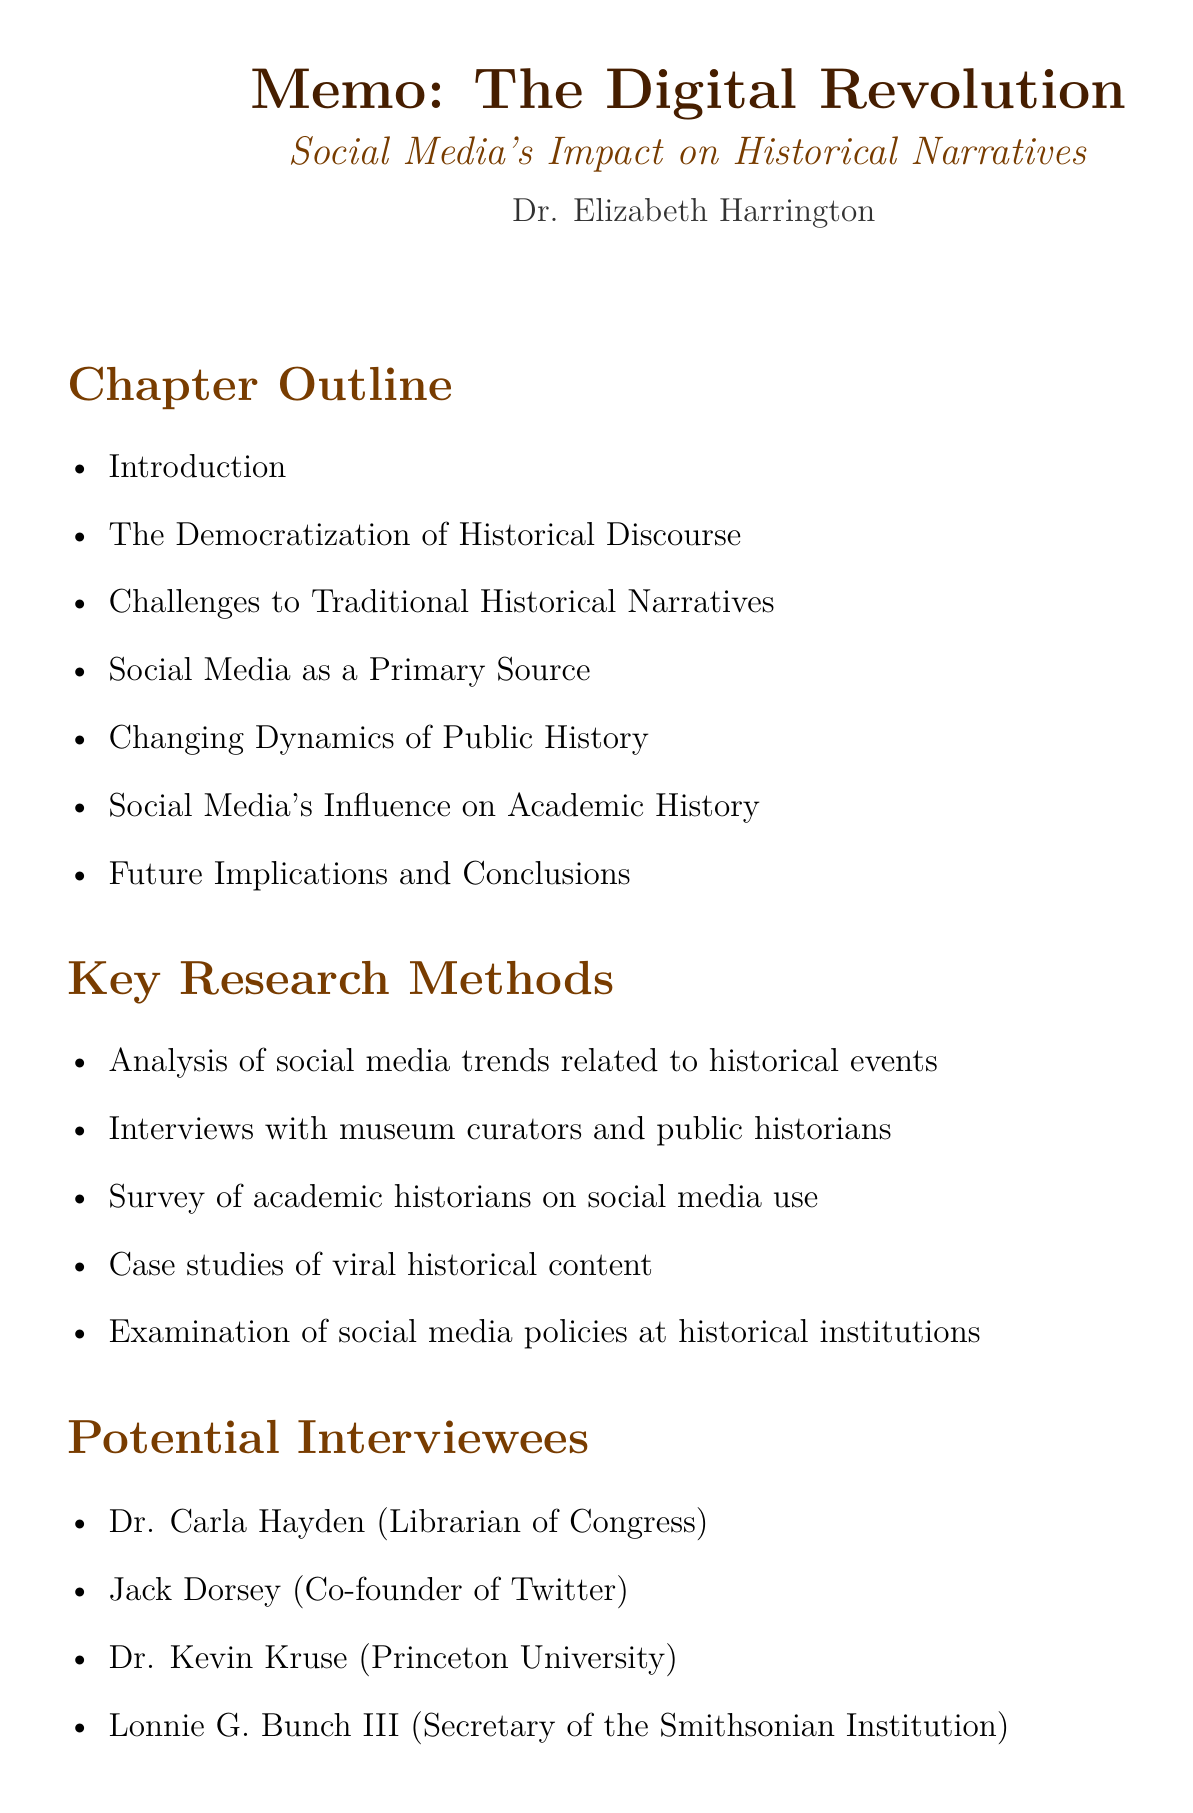what is the chapter title? The chapter title is explicitly stated at the beginning of the document.
Answer: The Digital Revolution: Social Media's Impact on Historical Narratives and Public Perception who is the author of the chapter? The author's name is provided in the document, highlighting their credibility.
Answer: Dr. Elizabeth Harrington what is one key research method mentioned? The document lists several research methods used in the study.
Answer: Analysis of social media trends related to historical events name one potential interviewee. The document includes a section on potential interviewees relevant to the topic.
Answer: Dr. Carla Hayden what year was "Digital Memory Studies: Media Pasts in Transition" published? The publication year for this reference is included in the key references section.
Answer: 2018 what is the focus of the introduction section? The introduction outlines the main themes and arguments of the chapter.
Answer: Brief overview of social media's rise and influence how many sections are outlined in the chapter? The document specifies the number of sections for clarity and structure.
Answer: Seven which social media platform's impact is examined in relation to the 1619 Project? The document discusses the influence of social media platforms on historical narratives.
Answer: Twitter what is one case study mentioned in the chapter outline? The chapter includes various case studies that highlight specific instances of historical discourse.
Answer: #BlackLivesMatter movement and its impact on discussions of racial history 